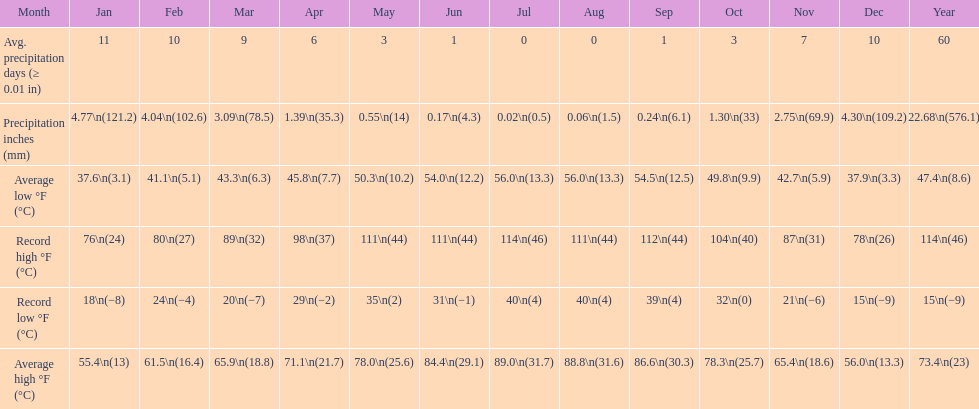Which month had an average high of 89.0 degrees and an average low of 56.0 degrees? July. 